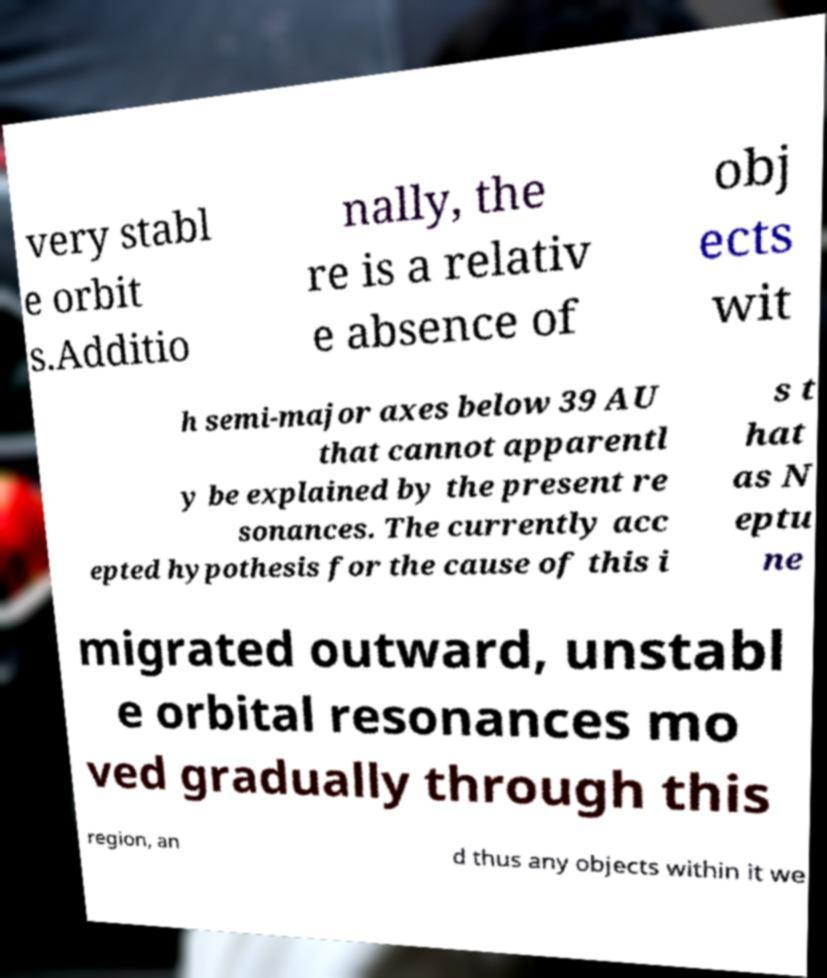Could you assist in decoding the text presented in this image and type it out clearly? very stabl e orbit s.Additio nally, the re is a relativ e absence of obj ects wit h semi-major axes below 39 AU that cannot apparentl y be explained by the present re sonances. The currently acc epted hypothesis for the cause of this i s t hat as N eptu ne migrated outward, unstabl e orbital resonances mo ved gradually through this region, an d thus any objects within it we 